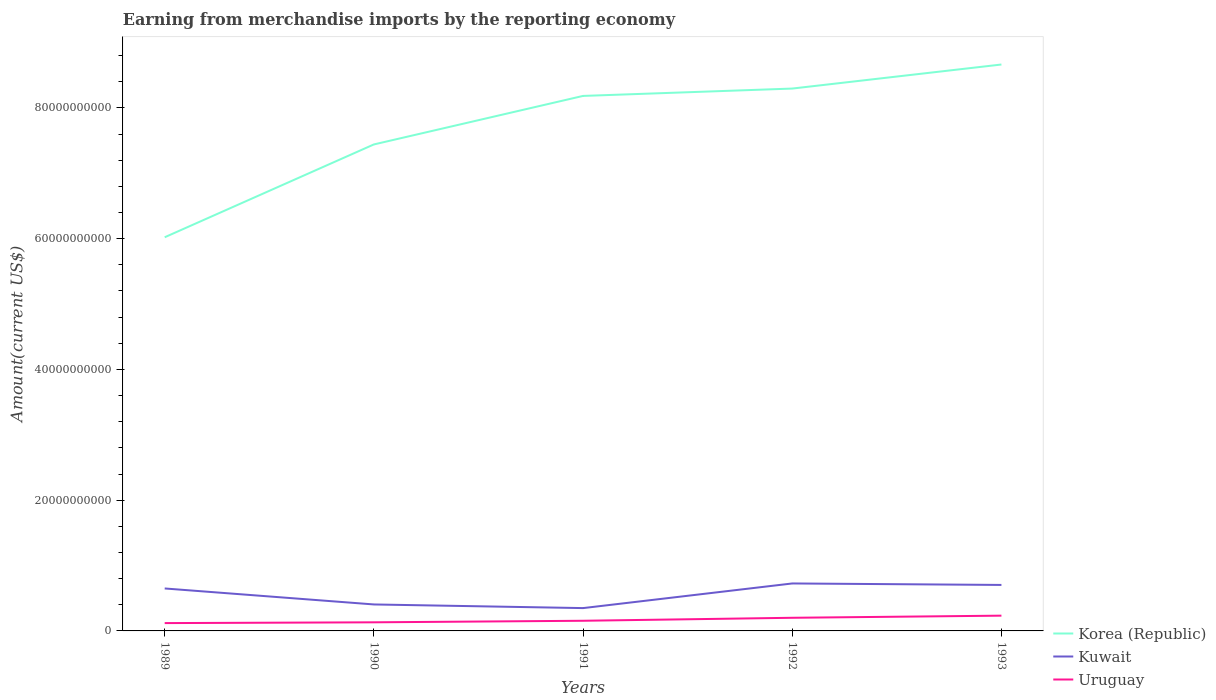How many different coloured lines are there?
Provide a succinct answer. 3. Does the line corresponding to Uruguay intersect with the line corresponding to Korea (Republic)?
Your response must be concise. No. Across all years, what is the maximum amount earned from merchandise imports in Kuwait?
Your answer should be compact. 3.49e+09. What is the total amount earned from merchandise imports in Uruguay in the graph?
Offer a terse response. -1.02e+09. What is the difference between the highest and the second highest amount earned from merchandise imports in Uruguay?
Offer a terse response. 1.14e+09. How many years are there in the graph?
Make the answer very short. 5. What is the difference between two consecutive major ticks on the Y-axis?
Keep it short and to the point. 2.00e+1. Are the values on the major ticks of Y-axis written in scientific E-notation?
Provide a succinct answer. No. Does the graph contain any zero values?
Your response must be concise. No. How are the legend labels stacked?
Provide a short and direct response. Vertical. What is the title of the graph?
Offer a terse response. Earning from merchandise imports by the reporting economy. What is the label or title of the Y-axis?
Provide a succinct answer. Amount(current US$). What is the Amount(current US$) in Korea (Republic) in 1989?
Offer a terse response. 6.02e+1. What is the Amount(current US$) of Kuwait in 1989?
Keep it short and to the point. 6.49e+09. What is the Amount(current US$) of Uruguay in 1989?
Offer a very short reply. 1.20e+09. What is the Amount(current US$) in Korea (Republic) in 1990?
Offer a terse response. 7.44e+1. What is the Amount(current US$) in Kuwait in 1990?
Your response must be concise. 4.05e+09. What is the Amount(current US$) in Uruguay in 1990?
Ensure brevity in your answer.  1.32e+09. What is the Amount(current US$) in Korea (Republic) in 1991?
Provide a succinct answer. 8.18e+1. What is the Amount(current US$) of Kuwait in 1991?
Your answer should be very brief. 3.49e+09. What is the Amount(current US$) of Uruguay in 1991?
Your answer should be very brief. 1.55e+09. What is the Amount(current US$) of Korea (Republic) in 1992?
Keep it short and to the point. 8.30e+1. What is the Amount(current US$) of Kuwait in 1992?
Provide a short and direct response. 7.26e+09. What is the Amount(current US$) in Uruguay in 1992?
Give a very brief answer. 2.01e+09. What is the Amount(current US$) of Korea (Republic) in 1993?
Keep it short and to the point. 8.66e+1. What is the Amount(current US$) in Kuwait in 1993?
Offer a very short reply. 7.03e+09. What is the Amount(current US$) of Uruguay in 1993?
Make the answer very short. 2.34e+09. Across all years, what is the maximum Amount(current US$) of Korea (Republic)?
Provide a succinct answer. 8.66e+1. Across all years, what is the maximum Amount(current US$) in Kuwait?
Offer a terse response. 7.26e+09. Across all years, what is the maximum Amount(current US$) of Uruguay?
Ensure brevity in your answer.  2.34e+09. Across all years, what is the minimum Amount(current US$) of Korea (Republic)?
Provide a short and direct response. 6.02e+1. Across all years, what is the minimum Amount(current US$) in Kuwait?
Your answer should be very brief. 3.49e+09. Across all years, what is the minimum Amount(current US$) of Uruguay?
Provide a short and direct response. 1.20e+09. What is the total Amount(current US$) in Korea (Republic) in the graph?
Your response must be concise. 3.86e+11. What is the total Amount(current US$) of Kuwait in the graph?
Ensure brevity in your answer.  2.83e+1. What is the total Amount(current US$) in Uruguay in the graph?
Provide a short and direct response. 8.41e+09. What is the difference between the Amount(current US$) in Korea (Republic) in 1989 and that in 1990?
Ensure brevity in your answer.  -1.42e+1. What is the difference between the Amount(current US$) in Kuwait in 1989 and that in 1990?
Keep it short and to the point. 2.44e+09. What is the difference between the Amount(current US$) of Uruguay in 1989 and that in 1990?
Your answer should be compact. -1.20e+08. What is the difference between the Amount(current US$) in Korea (Republic) in 1989 and that in 1991?
Your response must be concise. -2.16e+1. What is the difference between the Amount(current US$) of Kuwait in 1989 and that in 1991?
Provide a short and direct response. 3.00e+09. What is the difference between the Amount(current US$) of Uruguay in 1989 and that in 1991?
Your answer should be compact. -3.55e+08. What is the difference between the Amount(current US$) of Korea (Republic) in 1989 and that in 1992?
Make the answer very short. -2.27e+1. What is the difference between the Amount(current US$) of Kuwait in 1989 and that in 1992?
Offer a very short reply. -7.65e+08. What is the difference between the Amount(current US$) of Uruguay in 1989 and that in 1992?
Your answer should be very brief. -8.13e+08. What is the difference between the Amount(current US$) of Korea (Republic) in 1989 and that in 1993?
Make the answer very short. -2.64e+1. What is the difference between the Amount(current US$) of Kuwait in 1989 and that in 1993?
Your answer should be very brief. -5.38e+08. What is the difference between the Amount(current US$) of Uruguay in 1989 and that in 1993?
Keep it short and to the point. -1.14e+09. What is the difference between the Amount(current US$) in Korea (Republic) in 1990 and that in 1991?
Give a very brief answer. -7.42e+09. What is the difference between the Amount(current US$) in Kuwait in 1990 and that in 1991?
Offer a terse response. 5.58e+08. What is the difference between the Amount(current US$) in Uruguay in 1990 and that in 1991?
Make the answer very short. -2.35e+08. What is the difference between the Amount(current US$) in Korea (Republic) in 1990 and that in 1992?
Ensure brevity in your answer.  -8.55e+09. What is the difference between the Amount(current US$) of Kuwait in 1990 and that in 1992?
Your answer should be very brief. -3.21e+09. What is the difference between the Amount(current US$) in Uruguay in 1990 and that in 1992?
Ensure brevity in your answer.  -6.93e+08. What is the difference between the Amount(current US$) in Korea (Republic) in 1990 and that in 1993?
Ensure brevity in your answer.  -1.22e+1. What is the difference between the Amount(current US$) of Kuwait in 1990 and that in 1993?
Your answer should be very brief. -2.98e+09. What is the difference between the Amount(current US$) in Uruguay in 1990 and that in 1993?
Offer a terse response. -1.02e+09. What is the difference between the Amount(current US$) of Korea (Republic) in 1991 and that in 1992?
Ensure brevity in your answer.  -1.12e+09. What is the difference between the Amount(current US$) in Kuwait in 1991 and that in 1992?
Give a very brief answer. -3.77e+09. What is the difference between the Amount(current US$) in Uruguay in 1991 and that in 1992?
Your answer should be compact. -4.58e+08. What is the difference between the Amount(current US$) of Korea (Republic) in 1991 and that in 1993?
Offer a terse response. -4.80e+09. What is the difference between the Amount(current US$) of Kuwait in 1991 and that in 1993?
Make the answer very short. -3.54e+09. What is the difference between the Amount(current US$) of Uruguay in 1991 and that in 1993?
Offer a terse response. -7.83e+08. What is the difference between the Amount(current US$) of Korea (Republic) in 1992 and that in 1993?
Offer a very short reply. -3.68e+09. What is the difference between the Amount(current US$) in Kuwait in 1992 and that in 1993?
Make the answer very short. 2.27e+08. What is the difference between the Amount(current US$) in Uruguay in 1992 and that in 1993?
Give a very brief answer. -3.26e+08. What is the difference between the Amount(current US$) in Korea (Republic) in 1989 and the Amount(current US$) in Kuwait in 1990?
Give a very brief answer. 5.62e+1. What is the difference between the Amount(current US$) in Korea (Republic) in 1989 and the Amount(current US$) in Uruguay in 1990?
Provide a succinct answer. 5.89e+1. What is the difference between the Amount(current US$) in Kuwait in 1989 and the Amount(current US$) in Uruguay in 1990?
Provide a short and direct response. 5.18e+09. What is the difference between the Amount(current US$) of Korea (Republic) in 1989 and the Amount(current US$) of Kuwait in 1991?
Make the answer very short. 5.67e+1. What is the difference between the Amount(current US$) in Korea (Republic) in 1989 and the Amount(current US$) in Uruguay in 1991?
Your response must be concise. 5.87e+1. What is the difference between the Amount(current US$) of Kuwait in 1989 and the Amount(current US$) of Uruguay in 1991?
Give a very brief answer. 4.94e+09. What is the difference between the Amount(current US$) in Korea (Republic) in 1989 and the Amount(current US$) in Kuwait in 1992?
Make the answer very short. 5.30e+1. What is the difference between the Amount(current US$) in Korea (Republic) in 1989 and the Amount(current US$) in Uruguay in 1992?
Make the answer very short. 5.82e+1. What is the difference between the Amount(current US$) of Kuwait in 1989 and the Amount(current US$) of Uruguay in 1992?
Provide a succinct answer. 4.48e+09. What is the difference between the Amount(current US$) of Korea (Republic) in 1989 and the Amount(current US$) of Kuwait in 1993?
Your answer should be compact. 5.32e+1. What is the difference between the Amount(current US$) in Korea (Republic) in 1989 and the Amount(current US$) in Uruguay in 1993?
Keep it short and to the point. 5.79e+1. What is the difference between the Amount(current US$) in Kuwait in 1989 and the Amount(current US$) in Uruguay in 1993?
Give a very brief answer. 4.16e+09. What is the difference between the Amount(current US$) in Korea (Republic) in 1990 and the Amount(current US$) in Kuwait in 1991?
Keep it short and to the point. 7.09e+1. What is the difference between the Amount(current US$) in Korea (Republic) in 1990 and the Amount(current US$) in Uruguay in 1991?
Ensure brevity in your answer.  7.29e+1. What is the difference between the Amount(current US$) in Kuwait in 1990 and the Amount(current US$) in Uruguay in 1991?
Offer a very short reply. 2.50e+09. What is the difference between the Amount(current US$) of Korea (Republic) in 1990 and the Amount(current US$) of Kuwait in 1992?
Offer a very short reply. 6.71e+1. What is the difference between the Amount(current US$) of Korea (Republic) in 1990 and the Amount(current US$) of Uruguay in 1992?
Make the answer very short. 7.24e+1. What is the difference between the Amount(current US$) in Kuwait in 1990 and the Amount(current US$) in Uruguay in 1992?
Offer a very short reply. 2.04e+09. What is the difference between the Amount(current US$) in Korea (Republic) in 1990 and the Amount(current US$) in Kuwait in 1993?
Provide a short and direct response. 6.74e+1. What is the difference between the Amount(current US$) of Korea (Republic) in 1990 and the Amount(current US$) of Uruguay in 1993?
Ensure brevity in your answer.  7.21e+1. What is the difference between the Amount(current US$) in Kuwait in 1990 and the Amount(current US$) in Uruguay in 1993?
Offer a terse response. 1.71e+09. What is the difference between the Amount(current US$) of Korea (Republic) in 1991 and the Amount(current US$) of Kuwait in 1992?
Your answer should be compact. 7.46e+1. What is the difference between the Amount(current US$) of Korea (Republic) in 1991 and the Amount(current US$) of Uruguay in 1992?
Make the answer very short. 7.98e+1. What is the difference between the Amount(current US$) in Kuwait in 1991 and the Amount(current US$) in Uruguay in 1992?
Give a very brief answer. 1.48e+09. What is the difference between the Amount(current US$) in Korea (Republic) in 1991 and the Amount(current US$) in Kuwait in 1993?
Keep it short and to the point. 7.48e+1. What is the difference between the Amount(current US$) of Korea (Republic) in 1991 and the Amount(current US$) of Uruguay in 1993?
Provide a succinct answer. 7.95e+1. What is the difference between the Amount(current US$) in Kuwait in 1991 and the Amount(current US$) in Uruguay in 1993?
Ensure brevity in your answer.  1.16e+09. What is the difference between the Amount(current US$) in Korea (Republic) in 1992 and the Amount(current US$) in Kuwait in 1993?
Your answer should be very brief. 7.59e+1. What is the difference between the Amount(current US$) of Korea (Republic) in 1992 and the Amount(current US$) of Uruguay in 1993?
Give a very brief answer. 8.06e+1. What is the difference between the Amount(current US$) in Kuwait in 1992 and the Amount(current US$) in Uruguay in 1993?
Give a very brief answer. 4.92e+09. What is the average Amount(current US$) of Korea (Republic) per year?
Give a very brief answer. 7.72e+1. What is the average Amount(current US$) in Kuwait per year?
Offer a very short reply. 5.66e+09. What is the average Amount(current US$) in Uruguay per year?
Ensure brevity in your answer.  1.68e+09. In the year 1989, what is the difference between the Amount(current US$) in Korea (Republic) and Amount(current US$) in Kuwait?
Offer a terse response. 5.37e+1. In the year 1989, what is the difference between the Amount(current US$) of Korea (Republic) and Amount(current US$) of Uruguay?
Provide a short and direct response. 5.90e+1. In the year 1989, what is the difference between the Amount(current US$) of Kuwait and Amount(current US$) of Uruguay?
Offer a terse response. 5.30e+09. In the year 1990, what is the difference between the Amount(current US$) of Korea (Republic) and Amount(current US$) of Kuwait?
Your response must be concise. 7.04e+1. In the year 1990, what is the difference between the Amount(current US$) of Korea (Republic) and Amount(current US$) of Uruguay?
Offer a terse response. 7.31e+1. In the year 1990, what is the difference between the Amount(current US$) of Kuwait and Amount(current US$) of Uruguay?
Your answer should be compact. 2.73e+09. In the year 1991, what is the difference between the Amount(current US$) in Korea (Republic) and Amount(current US$) in Kuwait?
Keep it short and to the point. 7.83e+1. In the year 1991, what is the difference between the Amount(current US$) in Korea (Republic) and Amount(current US$) in Uruguay?
Offer a very short reply. 8.03e+1. In the year 1991, what is the difference between the Amount(current US$) of Kuwait and Amount(current US$) of Uruguay?
Provide a succinct answer. 1.94e+09. In the year 1992, what is the difference between the Amount(current US$) in Korea (Republic) and Amount(current US$) in Kuwait?
Ensure brevity in your answer.  7.57e+1. In the year 1992, what is the difference between the Amount(current US$) of Korea (Republic) and Amount(current US$) of Uruguay?
Offer a terse response. 8.09e+1. In the year 1992, what is the difference between the Amount(current US$) in Kuwait and Amount(current US$) in Uruguay?
Make the answer very short. 5.25e+09. In the year 1993, what is the difference between the Amount(current US$) in Korea (Republic) and Amount(current US$) in Kuwait?
Your answer should be very brief. 7.96e+1. In the year 1993, what is the difference between the Amount(current US$) of Korea (Republic) and Amount(current US$) of Uruguay?
Your response must be concise. 8.43e+1. In the year 1993, what is the difference between the Amount(current US$) of Kuwait and Amount(current US$) of Uruguay?
Make the answer very short. 4.70e+09. What is the ratio of the Amount(current US$) in Korea (Republic) in 1989 to that in 1990?
Your answer should be very brief. 0.81. What is the ratio of the Amount(current US$) in Kuwait in 1989 to that in 1990?
Provide a short and direct response. 1.6. What is the ratio of the Amount(current US$) of Uruguay in 1989 to that in 1990?
Provide a succinct answer. 0.91. What is the ratio of the Amount(current US$) of Korea (Republic) in 1989 to that in 1991?
Offer a very short reply. 0.74. What is the ratio of the Amount(current US$) of Kuwait in 1989 to that in 1991?
Make the answer very short. 1.86. What is the ratio of the Amount(current US$) of Uruguay in 1989 to that in 1991?
Offer a terse response. 0.77. What is the ratio of the Amount(current US$) in Korea (Republic) in 1989 to that in 1992?
Your response must be concise. 0.73. What is the ratio of the Amount(current US$) of Kuwait in 1989 to that in 1992?
Your response must be concise. 0.89. What is the ratio of the Amount(current US$) in Uruguay in 1989 to that in 1992?
Ensure brevity in your answer.  0.6. What is the ratio of the Amount(current US$) in Korea (Republic) in 1989 to that in 1993?
Give a very brief answer. 0.69. What is the ratio of the Amount(current US$) in Kuwait in 1989 to that in 1993?
Provide a short and direct response. 0.92. What is the ratio of the Amount(current US$) of Uruguay in 1989 to that in 1993?
Give a very brief answer. 0.51. What is the ratio of the Amount(current US$) in Korea (Republic) in 1990 to that in 1991?
Offer a very short reply. 0.91. What is the ratio of the Amount(current US$) of Kuwait in 1990 to that in 1991?
Offer a very short reply. 1.16. What is the ratio of the Amount(current US$) of Uruguay in 1990 to that in 1991?
Ensure brevity in your answer.  0.85. What is the ratio of the Amount(current US$) in Korea (Republic) in 1990 to that in 1992?
Your answer should be very brief. 0.9. What is the ratio of the Amount(current US$) of Kuwait in 1990 to that in 1992?
Your answer should be compact. 0.56. What is the ratio of the Amount(current US$) of Uruguay in 1990 to that in 1992?
Ensure brevity in your answer.  0.66. What is the ratio of the Amount(current US$) in Korea (Republic) in 1990 to that in 1993?
Keep it short and to the point. 0.86. What is the ratio of the Amount(current US$) of Kuwait in 1990 to that in 1993?
Provide a succinct answer. 0.58. What is the ratio of the Amount(current US$) in Uruguay in 1990 to that in 1993?
Ensure brevity in your answer.  0.56. What is the ratio of the Amount(current US$) of Korea (Republic) in 1991 to that in 1992?
Make the answer very short. 0.99. What is the ratio of the Amount(current US$) of Kuwait in 1991 to that in 1992?
Your response must be concise. 0.48. What is the ratio of the Amount(current US$) in Uruguay in 1991 to that in 1992?
Keep it short and to the point. 0.77. What is the ratio of the Amount(current US$) of Korea (Republic) in 1991 to that in 1993?
Your response must be concise. 0.94. What is the ratio of the Amount(current US$) of Kuwait in 1991 to that in 1993?
Give a very brief answer. 0.5. What is the ratio of the Amount(current US$) of Uruguay in 1991 to that in 1993?
Provide a short and direct response. 0.66. What is the ratio of the Amount(current US$) in Korea (Republic) in 1992 to that in 1993?
Your answer should be very brief. 0.96. What is the ratio of the Amount(current US$) in Kuwait in 1992 to that in 1993?
Your response must be concise. 1.03. What is the ratio of the Amount(current US$) of Uruguay in 1992 to that in 1993?
Your answer should be compact. 0.86. What is the difference between the highest and the second highest Amount(current US$) in Korea (Republic)?
Make the answer very short. 3.68e+09. What is the difference between the highest and the second highest Amount(current US$) in Kuwait?
Your response must be concise. 2.27e+08. What is the difference between the highest and the second highest Amount(current US$) in Uruguay?
Offer a terse response. 3.26e+08. What is the difference between the highest and the lowest Amount(current US$) in Korea (Republic)?
Give a very brief answer. 2.64e+1. What is the difference between the highest and the lowest Amount(current US$) of Kuwait?
Offer a very short reply. 3.77e+09. What is the difference between the highest and the lowest Amount(current US$) in Uruguay?
Make the answer very short. 1.14e+09. 